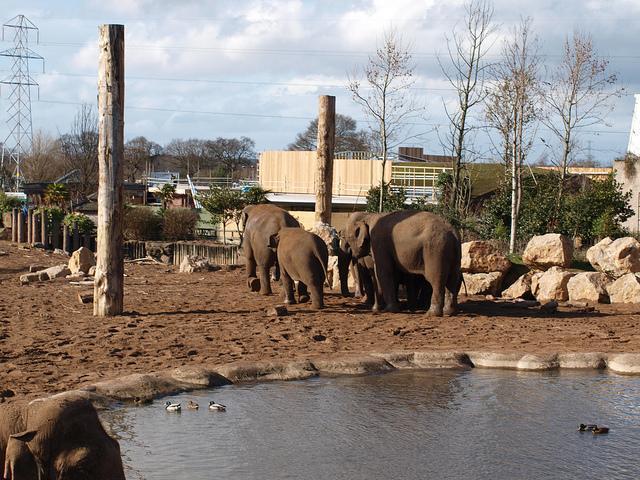How many elephants are in the photo?
Give a very brief answer. 4. How many giraffes are in this photo?
Give a very brief answer. 0. 